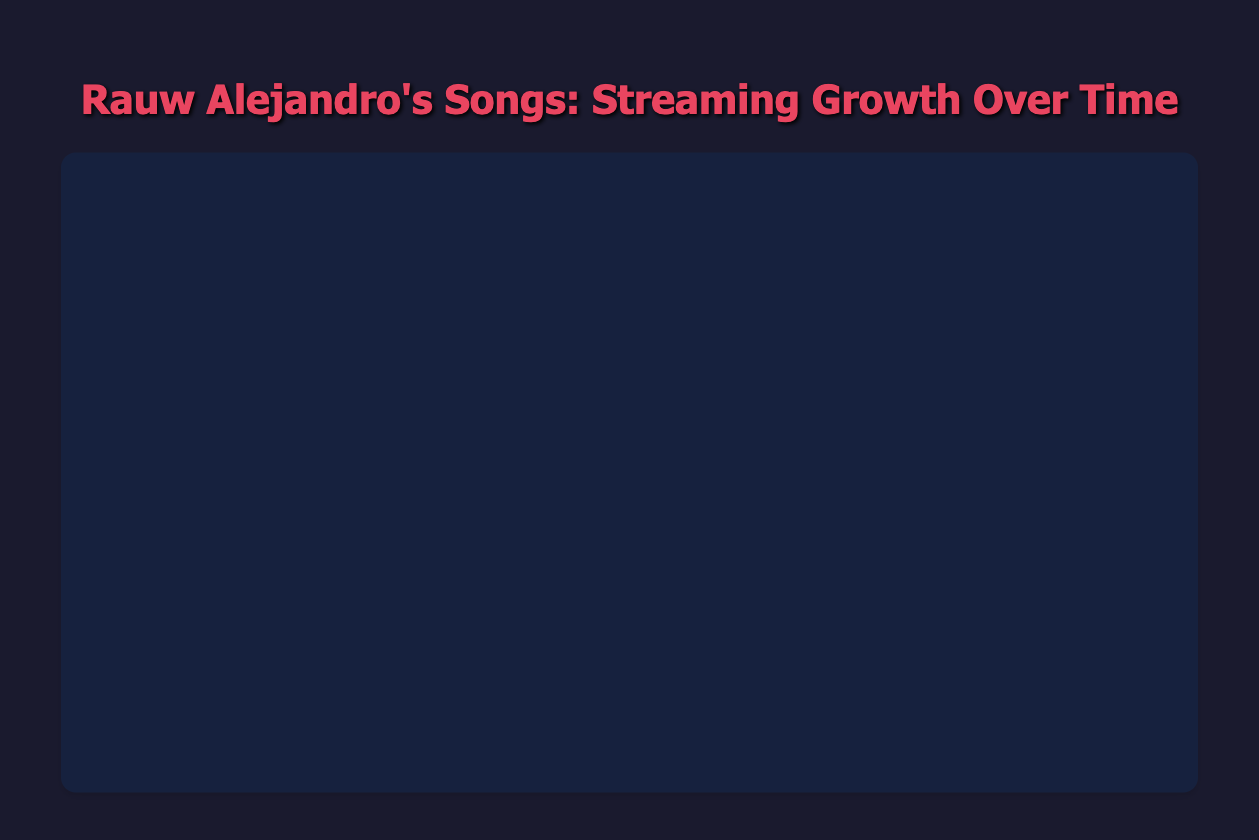What's the total number of streams for "Todo de Ti" by March 2022? To find the total streams by March 2022, sum the streams recorded each month from June 2021 to March 2022. The values are: 1,500,000 + 6,000,000 + 13,000,000 + 20,000,000 + 28,000,000 + 37,000,000 + 46,000,000 + 54,000,000 + 61,000,000 + 67,000,000 = 333,500,000
Answer: 333,500,000 Which song had the highest number of streams by September 2021? Compare the number of streams for each song by September 2021: "Todo de Ti" (20,000,000), "Cúrame" (15,300,000), "2/Catorce" (12,500,000), "La Old Skul" reached its peak in October 2019, so it is not relevant. "Todo de Ti" has the highest streams by September 2021.
Answer: Todo de Ti Between “Cúrame” and “2/Catorce,” which song had faster initial growth in the first three months after release? For "Cúrame", from December 2020 to February 2021: 300,000 to 2,000,000 streams. For "2/Catorce", from March 2021 to May 2021: 1,200,000 to 5,000,000 streams. "2/Catorce" had a higher increase in streams (3,800,000 vs. 1,700,000) in its first three months.
Answer: 2/Catorce Which song experienced the most streams growth in a single month? Check each monthly increase for all songs. The highest single-month growth for "Todo de Ti" was between July 2021 (6,000,000) and August 2021 (13,000,000), which is an increase of 7,000,000 streams. This is the highest compared to the others.
Answer: Todo de Ti What’s the average monthly growth rate of “La Old Skul” during its streaming tracking period? Determine the total growth from January 2019 (50,000) to October 2019 (3,500,000), and divide it by the number of months (10). The growth is 3,500,000 - 50,000 = 3,450,000 over 10 months. Then, 3,450,000 / 10 = 345,000 streams per month on average.
Answer: 345,000 Which song had the smoothest streaming growth with the least fluctuation in its curve? Visually inspect the line chart for the song with the most consistently increasing line without sharp spikes or drops. "Cúrame" shows the smoothest and most consistent growth pattern compared to others.
Answer: Cúrame How many times did "2/Catorce" double its streams from March 2021 to December 2021? From March 2021 (1,200,000) to April 2021 (2,700,000): More than doubled. Next, from April 2021 (2,700,000) to May 2021 (5,000,000): Less than doubled, and no further doubling observed in subsequent months. "2/Catorce" doubled its streams once.
Answer: Once What month did "Todo de Ti" surpass 50 million streams? Observing the streaming data for "Todo de Ti," it first surpasses 50 million streams in February 2022 with 61,000,000 streams.
Answer: February 2022 How does the streaming growth of “2/Catorce” from April to September 2021 compare to that of “Cúrame” from the same period? Calculate growth for "2/Catorce" and "Cúrame" from April to September 2021. "2/Catorce" went from 2,700,000 to 12,500,000: 12,500,000 - 2,700,000 = 9,800,000. "Cúrame" went from 5,000,000 to 15,300,000: 15,300,000 - 5,000,000 = 10,300,000. "Cúrame" had a higher growth of streams.
Answer: Cúrame What color represents "Todo de Ti" in the chart? Looking at the color descriptions, "Todo de Ti" is represented by the first color, which is red.
Answer: Red 